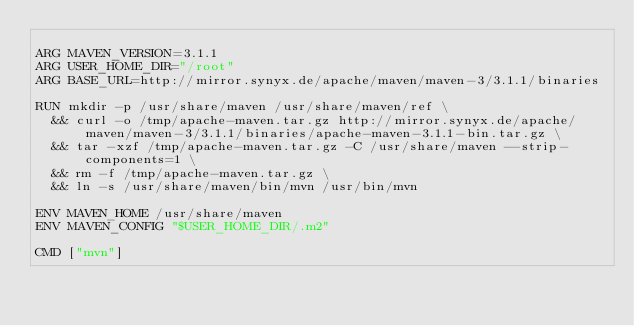<code> <loc_0><loc_0><loc_500><loc_500><_Dockerfile_>
ARG MAVEN_VERSION=3.1.1
ARG USER_HOME_DIR="/root"
ARG BASE_URL=http://mirror.synyx.de/apache/maven/maven-3/3.1.1/binaries

RUN mkdir -p /usr/share/maven /usr/share/maven/ref \
  && curl -o /tmp/apache-maven.tar.gz http://mirror.synyx.de/apache/maven/maven-3/3.1.1/binaries/apache-maven-3.1.1-bin.tar.gz \
  && tar -xzf /tmp/apache-maven.tar.gz -C /usr/share/maven --strip-components=1 \
  && rm -f /tmp/apache-maven.tar.gz \
  && ln -s /usr/share/maven/bin/mvn /usr/bin/mvn

ENV MAVEN_HOME /usr/share/maven
ENV MAVEN_CONFIG "$USER_HOME_DIR/.m2"

CMD ["mvn"]</code> 